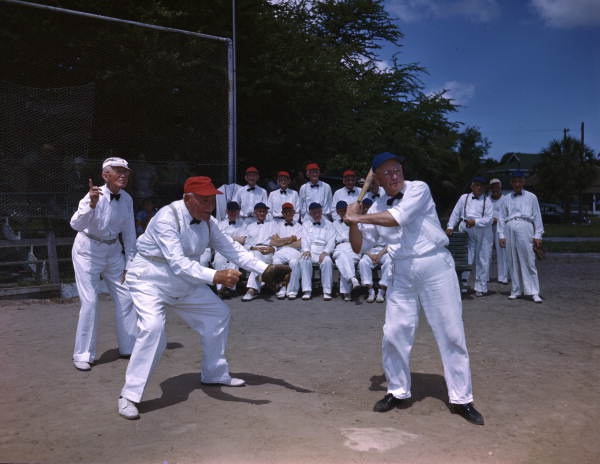Describe the objects in this image and their specific colors. I can see people in black, darkgray, gray, and lavender tones, people in black, lavender, gray, and darkgray tones, people in black, gray, and lavender tones, people in black, gray, and darkgray tones, and people in black, gray, and darkgray tones in this image. 